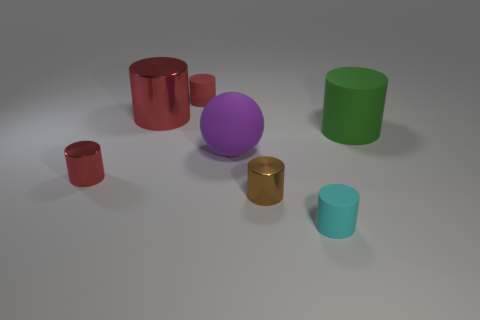Is there anything else that is the same shape as the big purple matte thing?
Give a very brief answer. No. The tiny red metal object has what shape?
Ensure brevity in your answer.  Cylinder. There is a large rubber thing on the left side of the small brown object; does it have the same shape as the big green matte thing?
Provide a short and direct response. No. Is the number of big rubber things right of the green cylinder greater than the number of matte cylinders to the left of the brown cylinder?
Give a very brief answer. No. How many other things are the same size as the green object?
Offer a terse response. 2. There is a cyan thing; does it have the same shape as the thing right of the cyan object?
Offer a terse response. Yes. How many matte objects are small red cylinders or green cylinders?
Your answer should be very brief. 2. Are there any small shiny things of the same color as the large metal cylinder?
Offer a terse response. Yes. Is there a cyan sphere?
Keep it short and to the point. No. Does the small brown metal object have the same shape as the big metal object?
Offer a terse response. Yes. 